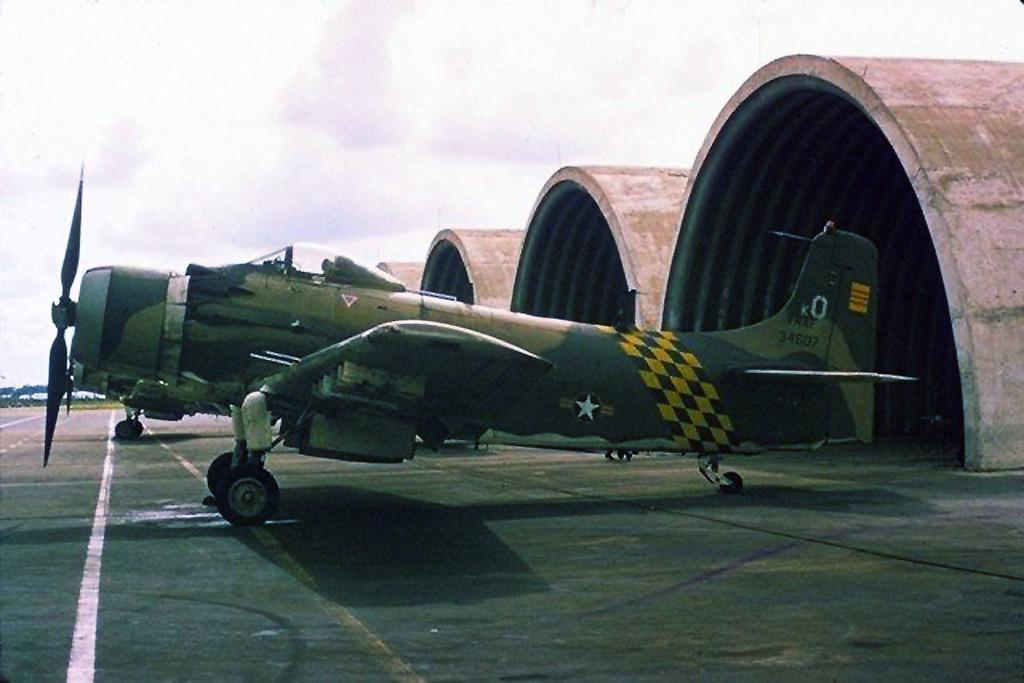<image>
Present a compact description of the photo's key features. An old military plane has the number 34607 on its tail. 